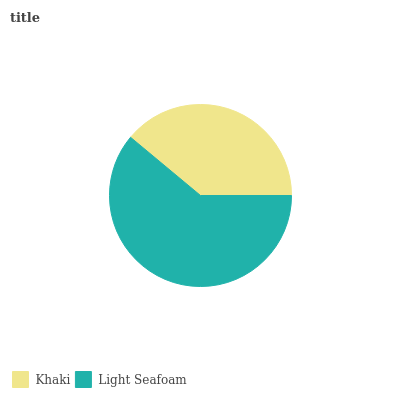Is Khaki the minimum?
Answer yes or no. Yes. Is Light Seafoam the maximum?
Answer yes or no. Yes. Is Light Seafoam the minimum?
Answer yes or no. No. Is Light Seafoam greater than Khaki?
Answer yes or no. Yes. Is Khaki less than Light Seafoam?
Answer yes or no. Yes. Is Khaki greater than Light Seafoam?
Answer yes or no. No. Is Light Seafoam less than Khaki?
Answer yes or no. No. Is Light Seafoam the high median?
Answer yes or no. Yes. Is Khaki the low median?
Answer yes or no. Yes. Is Khaki the high median?
Answer yes or no. No. Is Light Seafoam the low median?
Answer yes or no. No. 